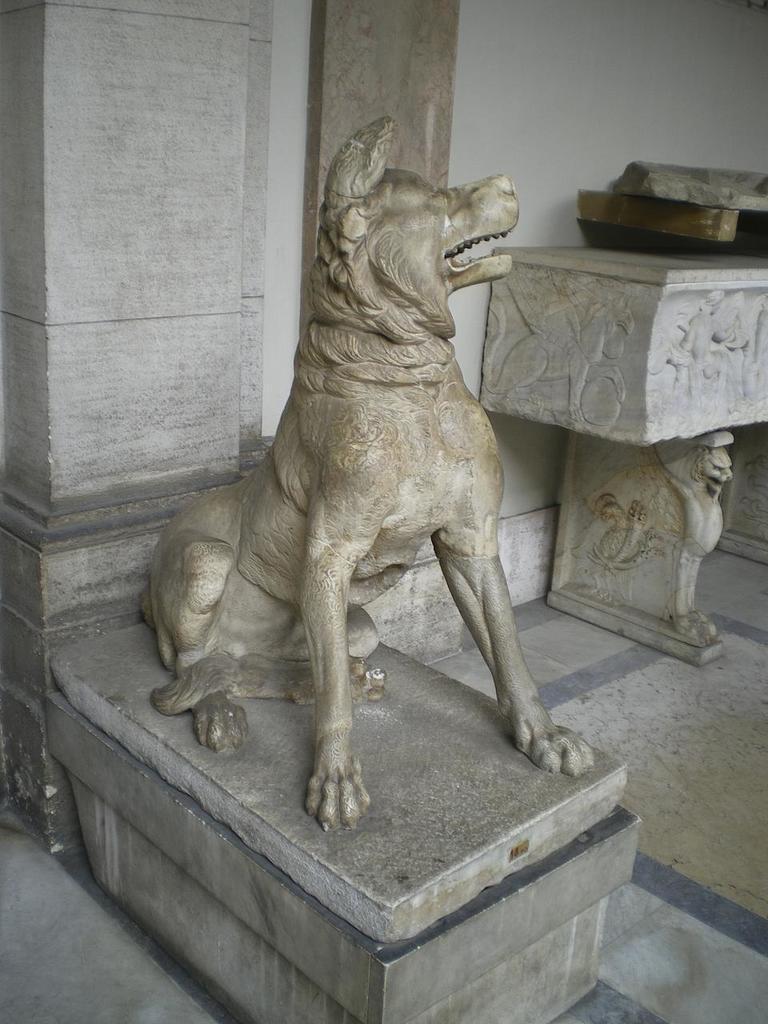In one or two sentences, can you explain what this image depicts? In this image I can see a sculpture of a dog and carved surfaces. 